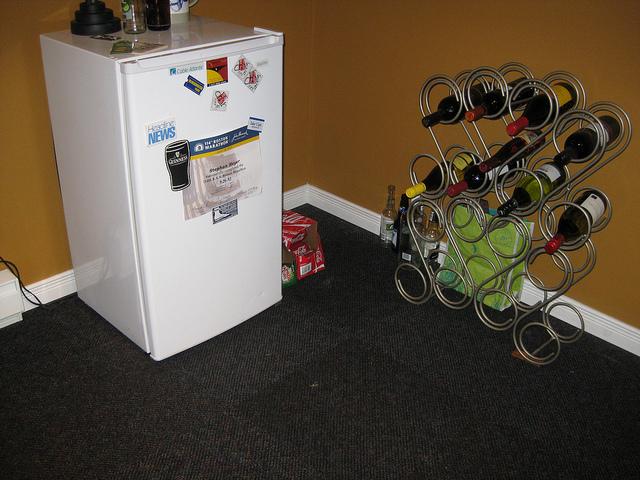What's on the fridge?
Give a very brief answer. Magnets. Is there any wine in the rack?
Short answer required. Yes. Where are the wine bottles?
Concise answer only. Rack. 